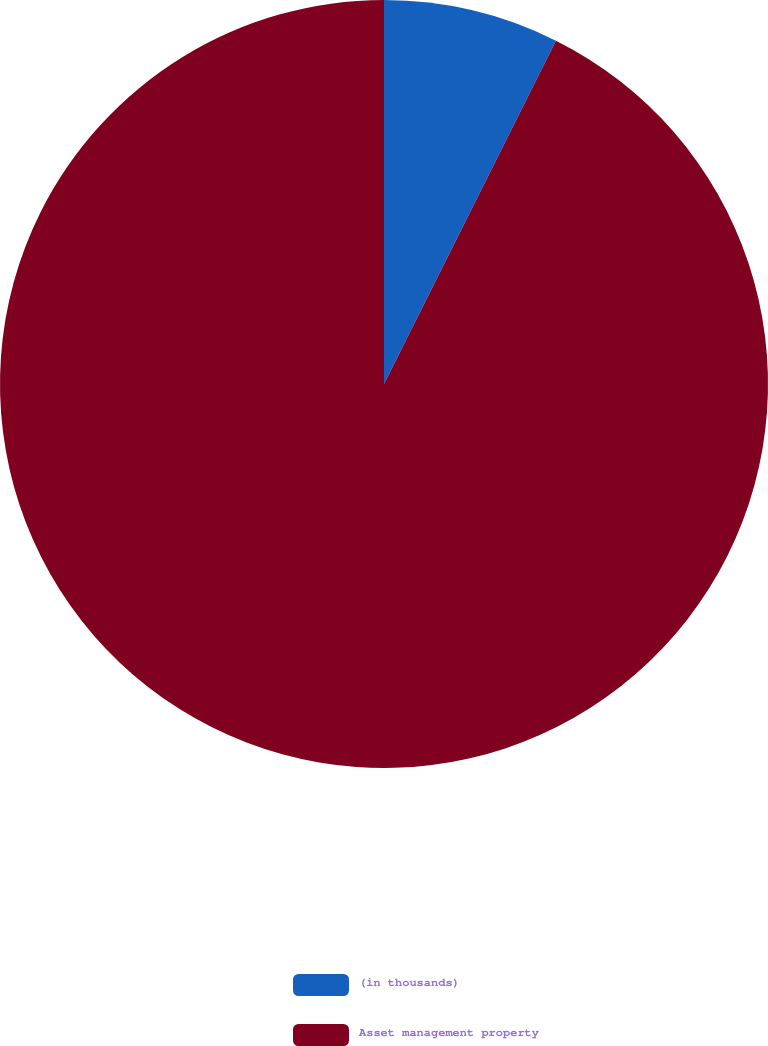<chart> <loc_0><loc_0><loc_500><loc_500><pie_chart><fcel>(in thousands)<fcel>Asset management property<nl><fcel>7.39%<fcel>92.61%<nl></chart> 